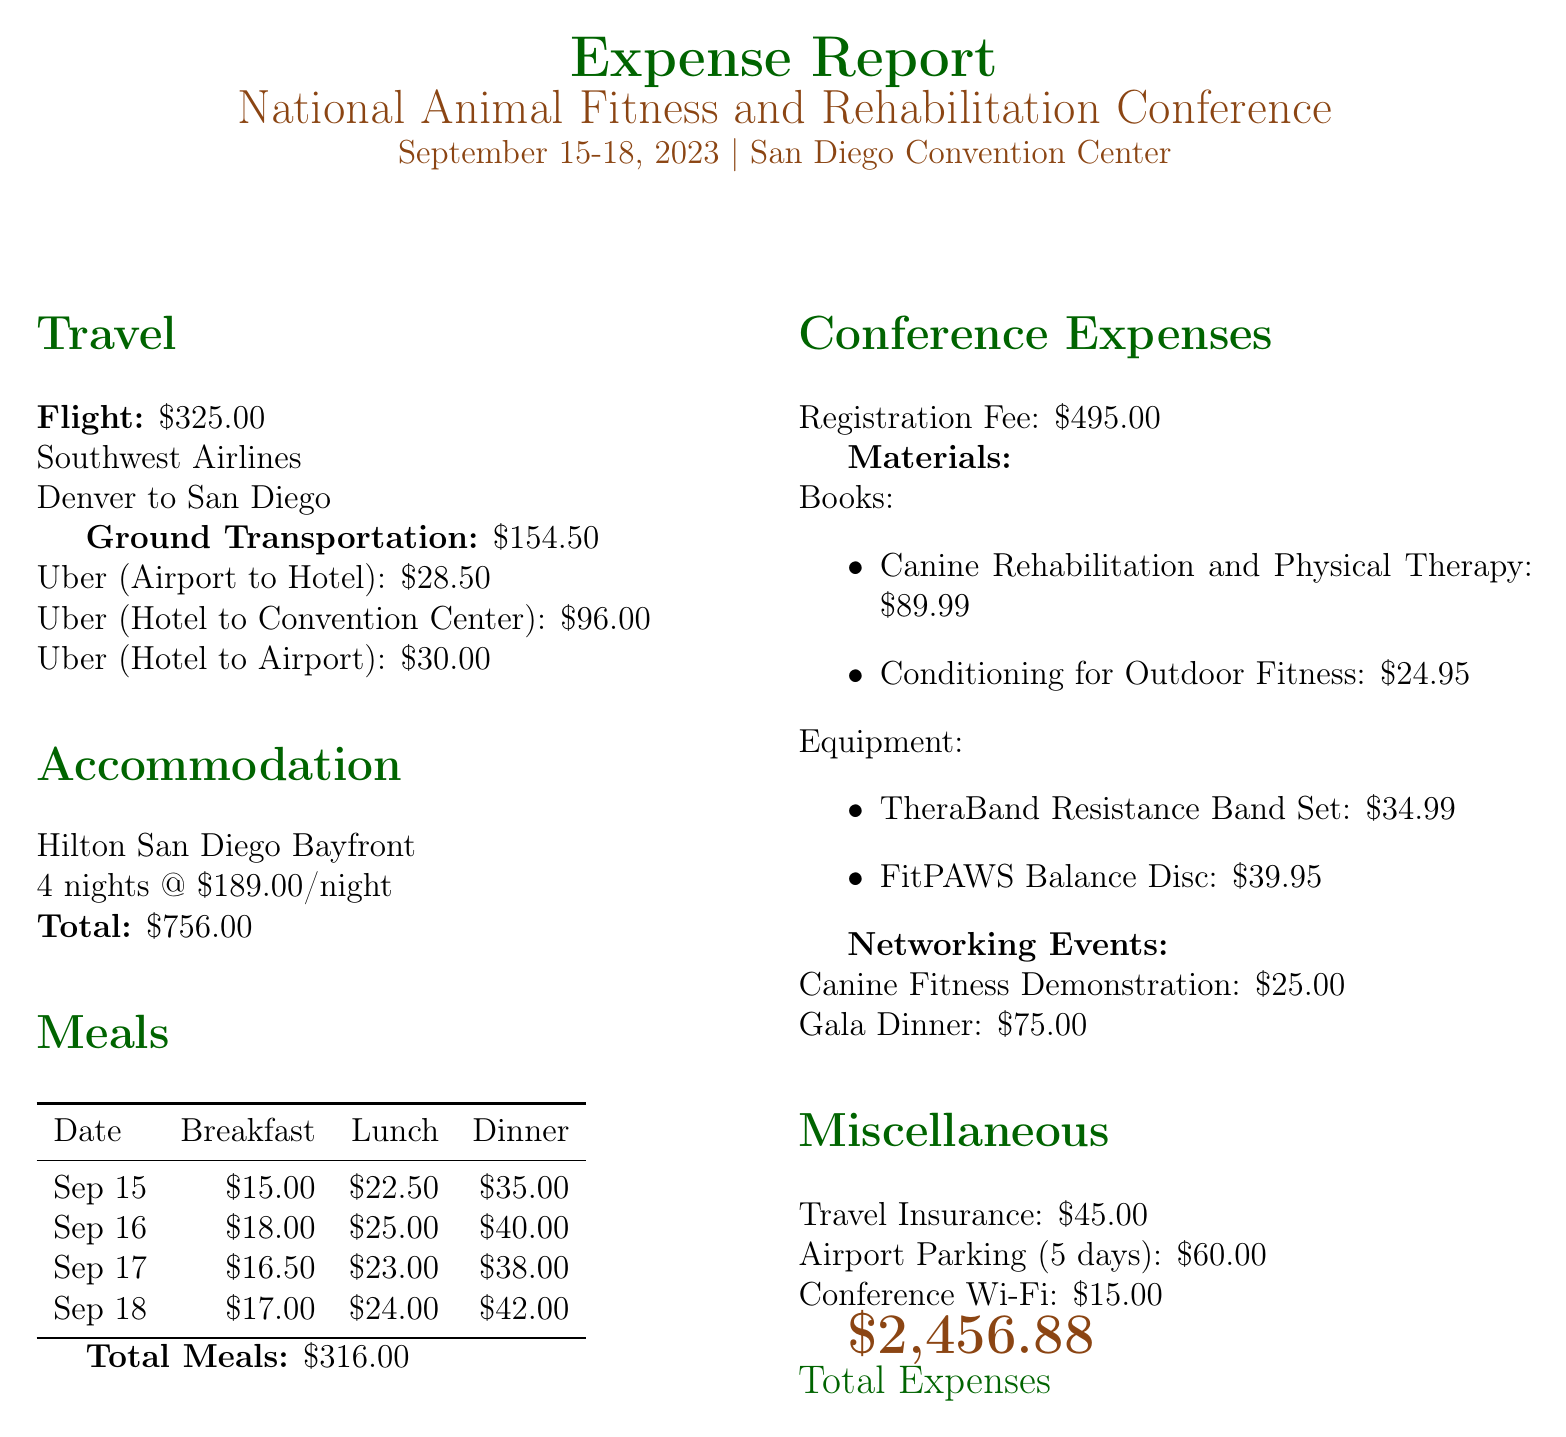What is the total travel cost? The total travel cost includes flight and ground transportation, which is $325.00 + $154.50 = $479.50.
Answer: $479.50 How many nights did the accommodation last? The document states that the accommodation was for 4 nights.
Answer: 4 nights What was the cost of the registration fee? The registration fee for the conference is explicitly listed as $495.00.
Answer: $495.00 How much did breakfast cost on September 17, 2023? The document provides a specific amount for breakfast on that date, which is $16.50.
Answer: $16.50 What are the titles of the books listed in conference materials? The titles mentioned are "Canine Rehabilitation and Physical Therapy" and "Conditioning for Outdoor Fitness."
Answer: "Canine Rehabilitation and Physical Therapy" and "Conditioning for Outdoor Fitness" What is the total cost for meals over the conference period? The total meal cost sums all breakfasts, lunches, and dinners, which is $316.00.
Answer: $316.00 How much was spent on networking events? The total cost for networking events includes $25.00 for the Canine Fitness Demonstration and $75.00 for the Gala Dinner, totaling $100.00.
Answer: $100.00 What is the total accommodation cost? The total accommodation cost is clearly stated as $756.00 for the 4 nights at $189.00 per night.
Answer: $756.00 What is the total expense reported in the document? The total expenses are calculated and listed at the end of the document as $2,456.88.
Answer: $2,456.88 